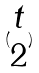<formula> <loc_0><loc_0><loc_500><loc_500>( \begin{matrix} t \\ 2 \end{matrix} )</formula> 